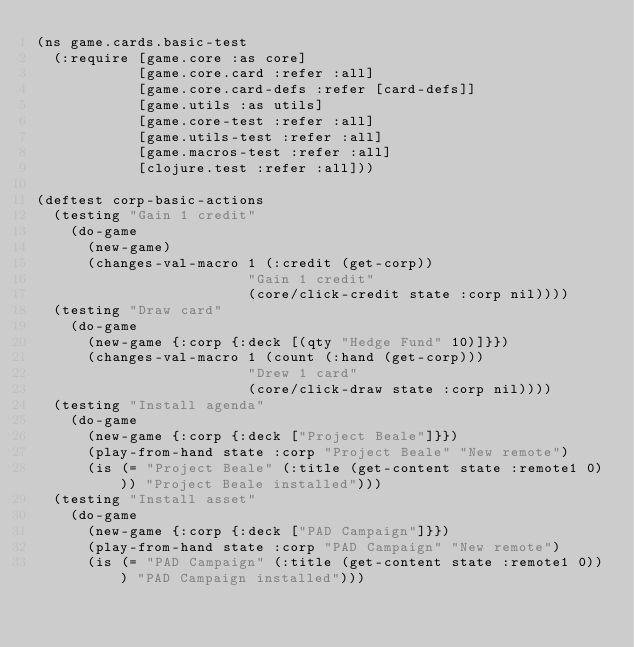<code> <loc_0><loc_0><loc_500><loc_500><_Clojure_>(ns game.cards.basic-test
  (:require [game.core :as core]
            [game.core.card :refer :all]
            [game.core.card-defs :refer [card-defs]]
            [game.utils :as utils]
            [game.core-test :refer :all]
            [game.utils-test :refer :all]
            [game.macros-test :refer :all]
            [clojure.test :refer :all]))

(deftest corp-basic-actions
  (testing "Gain 1 credit"
    (do-game
      (new-game)
      (changes-val-macro 1 (:credit (get-corp))
                         "Gain 1 credit"
                         (core/click-credit state :corp nil))))
  (testing "Draw card"
    (do-game
      (new-game {:corp {:deck [(qty "Hedge Fund" 10)]}})
      (changes-val-macro 1 (count (:hand (get-corp)))
                         "Drew 1 card"
                         (core/click-draw state :corp nil))))
  (testing "Install agenda"
    (do-game
      (new-game {:corp {:deck ["Project Beale"]}})
      (play-from-hand state :corp "Project Beale" "New remote")
      (is (= "Project Beale" (:title (get-content state :remote1 0))) "Project Beale installed")))
  (testing "Install asset"
    (do-game
      (new-game {:corp {:deck ["PAD Campaign"]}})
      (play-from-hand state :corp "PAD Campaign" "New remote")
      (is (= "PAD Campaign" (:title (get-content state :remote1 0))) "PAD Campaign installed")))</code> 